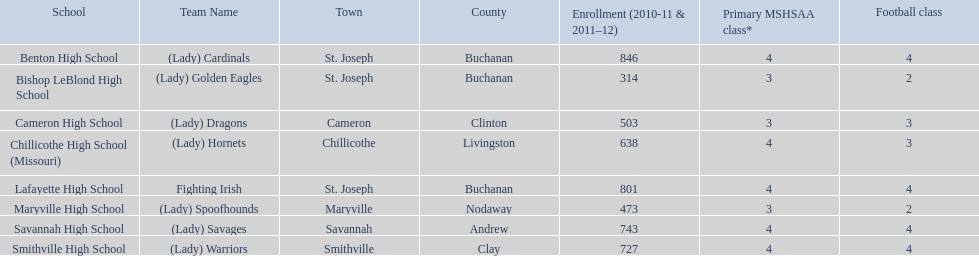What are all of the schools? Benton High School, Bishop LeBlond High School, Cameron High School, Chillicothe High School (Missouri), Lafayette High School, Maryville High School, Savannah High School, Smithville High School. How many football classes do they have? 4, 2, 3, 3, 4, 2, 4, 4. What about their enrollment? 846, 314, 503, 638, 801, 473, 743, 727. Which schools have 3 football classes? Cameron High School, Chillicothe High School (Missouri). And of those schools, which has 638 students? Chillicothe High School (Missouri). 